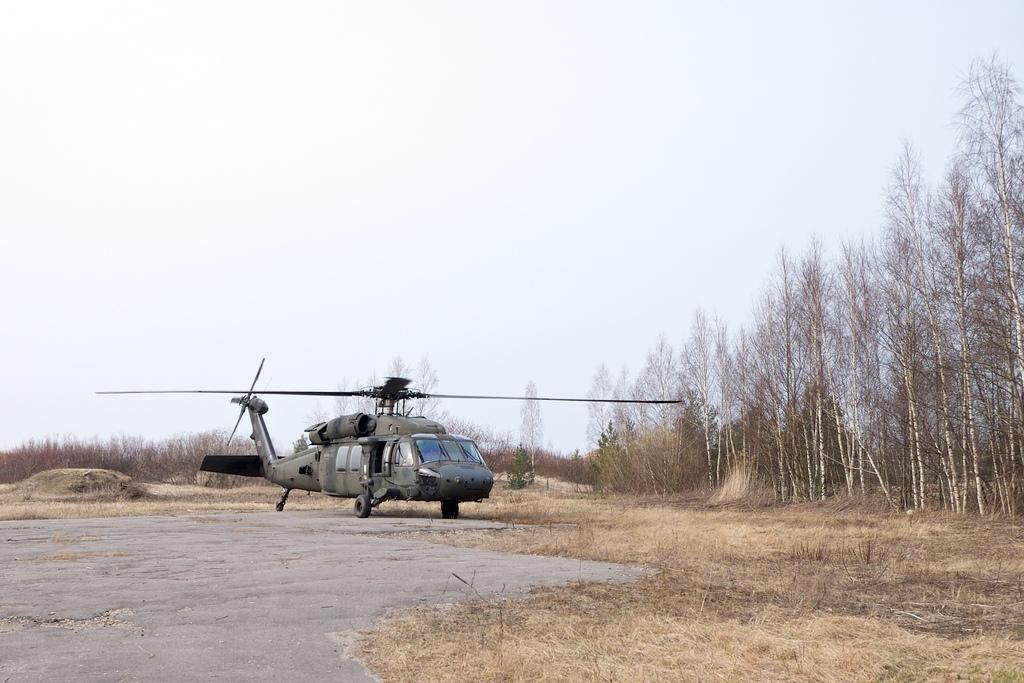What type of vehicle is on the ground in the image? There is a helicopter on the ground in the image. What type of vegetation is visible in the image? Dried grass is visible in the image. What other natural elements are present in the image? There are trees in the image. What is visible in the background of the image? The sky is visible in the background of the image. What type of stem can be seen growing from the helicopter in the image? There is no stem growing from the helicopter in the image. What type of legal advice is being given in the image? There is no lawyer or legal advice present in the image; it features a helicopter on the ground, dried grass, trees, and the sky. 